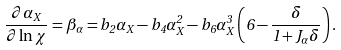Convert formula to latex. <formula><loc_0><loc_0><loc_500><loc_500>\frac { \partial \alpha _ { X } } { \partial \ln \chi } = \beta _ { \alpha } = b _ { 2 } \alpha _ { X } - b _ { 4 } \alpha ^ { 2 } _ { X } - b _ { 6 } \alpha ^ { 3 } _ { X } \left ( 6 - \frac { \delta } { 1 + J _ { \alpha } \delta } \right ) .</formula> 